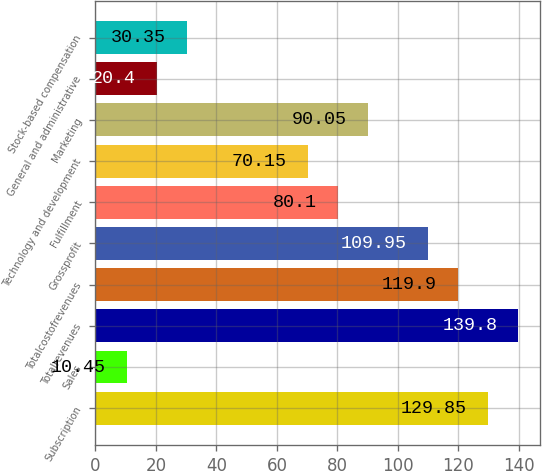Convert chart. <chart><loc_0><loc_0><loc_500><loc_500><bar_chart><fcel>Subscription<fcel>Sales<fcel>Totalrevenues<fcel>Totalcostofrevenues<fcel>Grossprofit<fcel>Fulfillment<fcel>Technology and development<fcel>Marketing<fcel>General and administrative<fcel>Stock-based compensation<nl><fcel>129.85<fcel>10.45<fcel>139.8<fcel>119.9<fcel>109.95<fcel>80.1<fcel>70.15<fcel>90.05<fcel>20.4<fcel>30.35<nl></chart> 